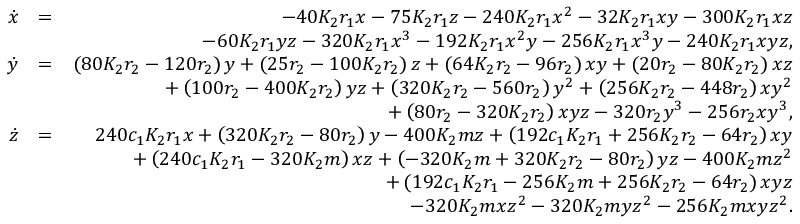<formula> <loc_0><loc_0><loc_500><loc_500>\begin{array} { r l r } { \dot { x } } & { = } & { - 4 0 K _ { 2 } r _ { 1 } x - 7 5 K _ { 2 } r _ { 1 } z - 2 4 0 K _ { 2 } r _ { 1 } x ^ { 2 } - 3 2 K _ { 2 } r _ { 1 } x y - 3 0 0 K _ { 2 } r _ { 1 } x z } \\ & { - 6 0 K _ { 2 } r _ { 1 } y z - 3 2 0 K _ { 2 } r _ { 1 } x ^ { 3 } - 1 9 2 K _ { 2 } r _ { 1 } x ^ { 2 } y - 2 5 6 K _ { 2 } r _ { 1 } x ^ { 3 } y - 2 4 0 K _ { 2 } r _ { 1 } x y z , } \\ { \dot { y } } & { = } & { \left ( 8 0 K _ { 2 } r _ { 2 } - 1 2 0 r _ { 2 } \right ) y + \left ( 2 5 r _ { 2 } - 1 0 0 K _ { 2 } r _ { 2 } \right ) z + \left ( 6 4 K _ { 2 } r _ { 2 } - 9 6 r _ { 2 } \right ) x y + \left ( 2 0 r _ { 2 } - 8 0 K _ { 2 } r _ { 2 } \right ) x z } \\ & { + \left ( 1 0 0 r _ { 2 } - 4 0 0 K _ { 2 } r _ { 2 } \right ) y z + \left ( 3 2 0 K _ { 2 } r _ { 2 } - 5 6 0 r _ { 2 } \right ) y ^ { 2 } + \left ( 2 5 6 K _ { 2 } r _ { 2 } - 4 4 8 r _ { 2 } \right ) x y ^ { 2 } } \\ & { + \left ( 8 0 r _ { 2 } - 3 2 0 K _ { 2 } r _ { 2 } \right ) x y z - 3 2 0 r _ { 2 } y ^ { 3 } - 2 5 6 r _ { 2 } x y ^ { 3 } , } \\ { \dot { z } } & { = } & { 2 4 0 c _ { 1 } K _ { 2 } r _ { 1 } x + \left ( 3 2 0 K _ { 2 } r _ { 2 } - 8 0 r _ { 2 } \right ) y - 4 0 0 K _ { 2 } m z + \left ( 1 9 2 c _ { 1 } K _ { 2 } r _ { 1 } + 2 5 6 K _ { 2 } r _ { 2 } - 6 4 r _ { 2 } \right ) x y } \\ & { + \left ( 2 4 0 c _ { 1 } K _ { 2 } r _ { 1 } - 3 2 0 K _ { 2 } m \right ) x z + \left ( - 3 2 0 K _ { 2 } m + 3 2 0 K _ { 2 } r _ { 2 } - 8 0 r _ { 2 } \right ) y z - 4 0 0 K _ { 2 } m z ^ { 2 } } \\ & { + \left ( 1 9 2 c _ { 1 } K _ { 2 } r _ { 1 } - 2 5 6 K _ { 2 } m + 2 5 6 K _ { 2 } r _ { 2 } - 6 4 r _ { 2 } \right ) x y z } \\ & { - 3 2 0 K _ { 2 } m x z ^ { 2 } - 3 2 0 K _ { 2 } m y z ^ { 2 } - 2 5 6 K _ { 2 } m x y z ^ { 2 } . } \end{array}</formula> 